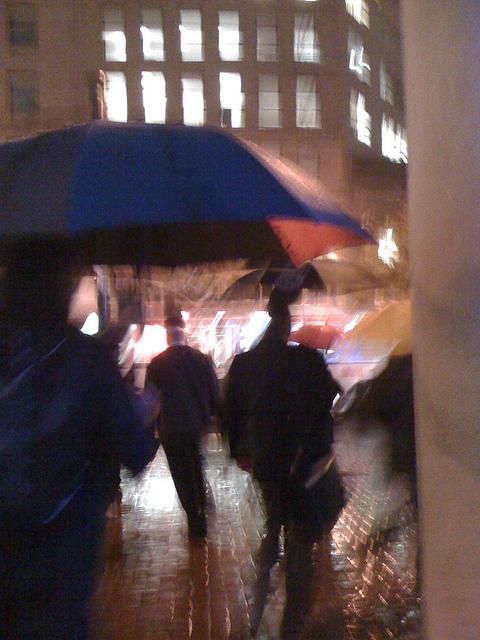Why is the scene dark?
Short answer required. Night. Is this picture blurry?
Be succinct. Yes. Are there umbrellas in this picture?
Keep it brief. Yes. 